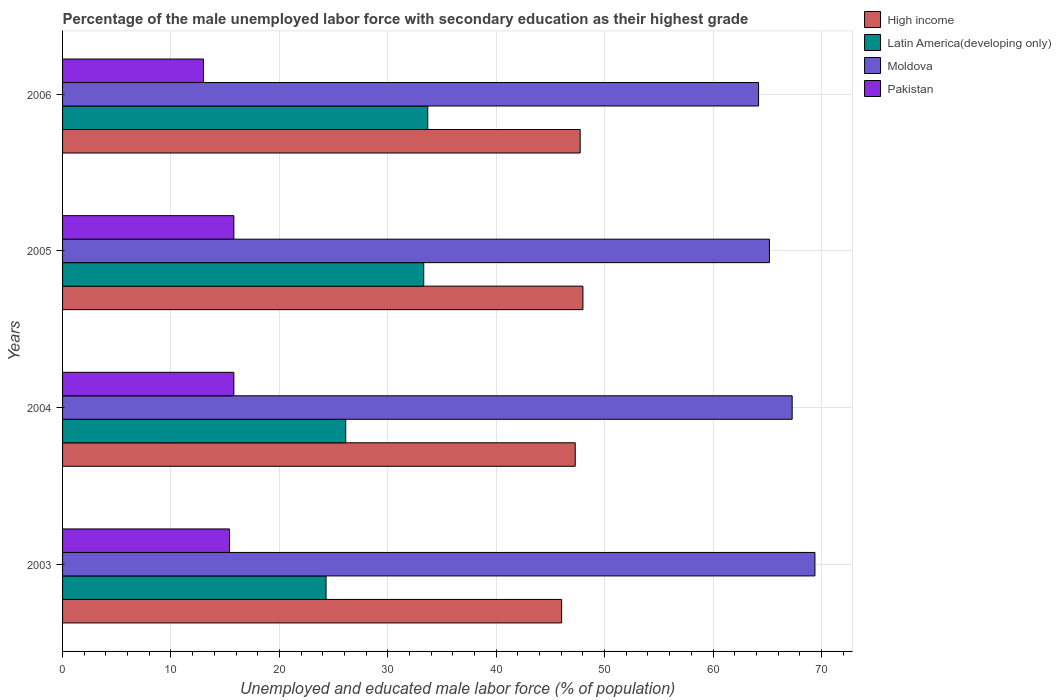Are the number of bars per tick equal to the number of legend labels?
Offer a terse response. Yes. What is the label of the 3rd group of bars from the top?
Provide a short and direct response. 2004. In how many cases, is the number of bars for a given year not equal to the number of legend labels?
Give a very brief answer. 0. What is the percentage of the unemployed male labor force with secondary education in Moldova in 2004?
Ensure brevity in your answer.  67.3. Across all years, what is the maximum percentage of the unemployed male labor force with secondary education in Pakistan?
Make the answer very short. 15.8. Across all years, what is the minimum percentage of the unemployed male labor force with secondary education in Latin America(developing only)?
Provide a succinct answer. 24.3. In which year was the percentage of the unemployed male labor force with secondary education in Moldova maximum?
Ensure brevity in your answer.  2003. In which year was the percentage of the unemployed male labor force with secondary education in Latin America(developing only) minimum?
Provide a succinct answer. 2003. What is the total percentage of the unemployed male labor force with secondary education in Pakistan in the graph?
Your answer should be very brief. 60. What is the difference between the percentage of the unemployed male labor force with secondary education in Latin America(developing only) in 2003 and that in 2005?
Give a very brief answer. -9.01. What is the difference between the percentage of the unemployed male labor force with secondary education in Pakistan in 2006 and the percentage of the unemployed male labor force with secondary education in Moldova in 2003?
Offer a very short reply. -56.4. What is the average percentage of the unemployed male labor force with secondary education in Pakistan per year?
Your answer should be compact. 15. In the year 2003, what is the difference between the percentage of the unemployed male labor force with secondary education in Latin America(developing only) and percentage of the unemployed male labor force with secondary education in Moldova?
Offer a terse response. -45.1. In how many years, is the percentage of the unemployed male labor force with secondary education in Pakistan greater than 22 %?
Offer a terse response. 0. What is the ratio of the percentage of the unemployed male labor force with secondary education in Moldova in 2004 to that in 2005?
Ensure brevity in your answer.  1.03. Is the percentage of the unemployed male labor force with secondary education in High income in 2004 less than that in 2005?
Offer a terse response. Yes. What is the difference between the highest and the second highest percentage of the unemployed male labor force with secondary education in Latin America(developing only)?
Your answer should be compact. 0.37. What is the difference between the highest and the lowest percentage of the unemployed male labor force with secondary education in Latin America(developing only)?
Keep it short and to the point. 9.38. In how many years, is the percentage of the unemployed male labor force with secondary education in High income greater than the average percentage of the unemployed male labor force with secondary education in High income taken over all years?
Ensure brevity in your answer.  3. Is the sum of the percentage of the unemployed male labor force with secondary education in High income in 2003 and 2006 greater than the maximum percentage of the unemployed male labor force with secondary education in Moldova across all years?
Offer a very short reply. Yes. Is it the case that in every year, the sum of the percentage of the unemployed male labor force with secondary education in Moldova and percentage of the unemployed male labor force with secondary education in Latin America(developing only) is greater than the sum of percentage of the unemployed male labor force with secondary education in High income and percentage of the unemployed male labor force with secondary education in Pakistan?
Your answer should be compact. No. What does the 2nd bar from the top in 2004 represents?
Your answer should be compact. Moldova. What does the 3rd bar from the bottom in 2006 represents?
Provide a succinct answer. Moldova. Is it the case that in every year, the sum of the percentage of the unemployed male labor force with secondary education in Latin America(developing only) and percentage of the unemployed male labor force with secondary education in High income is greater than the percentage of the unemployed male labor force with secondary education in Moldova?
Provide a short and direct response. Yes. What is the difference between two consecutive major ticks on the X-axis?
Ensure brevity in your answer.  10. How many legend labels are there?
Offer a very short reply. 4. How are the legend labels stacked?
Your response must be concise. Vertical. What is the title of the graph?
Your answer should be compact. Percentage of the male unemployed labor force with secondary education as their highest grade. Does "Ireland" appear as one of the legend labels in the graph?
Your answer should be compact. No. What is the label or title of the X-axis?
Your response must be concise. Unemployed and educated male labor force (% of population). What is the label or title of the Y-axis?
Your response must be concise. Years. What is the Unemployed and educated male labor force (% of population) of High income in 2003?
Keep it short and to the point. 46.04. What is the Unemployed and educated male labor force (% of population) of Latin America(developing only) in 2003?
Keep it short and to the point. 24.3. What is the Unemployed and educated male labor force (% of population) of Moldova in 2003?
Ensure brevity in your answer.  69.4. What is the Unemployed and educated male labor force (% of population) in Pakistan in 2003?
Your answer should be compact. 15.4. What is the Unemployed and educated male labor force (% of population) in High income in 2004?
Your answer should be compact. 47.29. What is the Unemployed and educated male labor force (% of population) in Latin America(developing only) in 2004?
Provide a short and direct response. 26.12. What is the Unemployed and educated male labor force (% of population) in Moldova in 2004?
Your answer should be very brief. 67.3. What is the Unemployed and educated male labor force (% of population) of Pakistan in 2004?
Give a very brief answer. 15.8. What is the Unemployed and educated male labor force (% of population) in High income in 2005?
Give a very brief answer. 48. What is the Unemployed and educated male labor force (% of population) in Latin America(developing only) in 2005?
Your answer should be very brief. 33.31. What is the Unemployed and educated male labor force (% of population) of Moldova in 2005?
Keep it short and to the point. 65.2. What is the Unemployed and educated male labor force (% of population) of Pakistan in 2005?
Offer a very short reply. 15.8. What is the Unemployed and educated male labor force (% of population) in High income in 2006?
Give a very brief answer. 47.74. What is the Unemployed and educated male labor force (% of population) in Latin America(developing only) in 2006?
Provide a succinct answer. 33.69. What is the Unemployed and educated male labor force (% of population) of Moldova in 2006?
Make the answer very short. 64.2. What is the Unemployed and educated male labor force (% of population) in Pakistan in 2006?
Offer a terse response. 13. Across all years, what is the maximum Unemployed and educated male labor force (% of population) in High income?
Keep it short and to the point. 48. Across all years, what is the maximum Unemployed and educated male labor force (% of population) of Latin America(developing only)?
Keep it short and to the point. 33.69. Across all years, what is the maximum Unemployed and educated male labor force (% of population) in Moldova?
Ensure brevity in your answer.  69.4. Across all years, what is the maximum Unemployed and educated male labor force (% of population) in Pakistan?
Ensure brevity in your answer.  15.8. Across all years, what is the minimum Unemployed and educated male labor force (% of population) in High income?
Offer a terse response. 46.04. Across all years, what is the minimum Unemployed and educated male labor force (% of population) in Latin America(developing only)?
Provide a succinct answer. 24.3. Across all years, what is the minimum Unemployed and educated male labor force (% of population) in Moldova?
Offer a terse response. 64.2. Across all years, what is the minimum Unemployed and educated male labor force (% of population) in Pakistan?
Offer a terse response. 13. What is the total Unemployed and educated male labor force (% of population) of High income in the graph?
Offer a very short reply. 189.07. What is the total Unemployed and educated male labor force (% of population) in Latin America(developing only) in the graph?
Keep it short and to the point. 117.43. What is the total Unemployed and educated male labor force (% of population) of Moldova in the graph?
Your response must be concise. 266.1. What is the total Unemployed and educated male labor force (% of population) of Pakistan in the graph?
Give a very brief answer. 60. What is the difference between the Unemployed and educated male labor force (% of population) of High income in 2003 and that in 2004?
Provide a short and direct response. -1.25. What is the difference between the Unemployed and educated male labor force (% of population) in Latin America(developing only) in 2003 and that in 2004?
Your response must be concise. -1.82. What is the difference between the Unemployed and educated male labor force (% of population) in Moldova in 2003 and that in 2004?
Offer a very short reply. 2.1. What is the difference between the Unemployed and educated male labor force (% of population) in Pakistan in 2003 and that in 2004?
Your answer should be compact. -0.4. What is the difference between the Unemployed and educated male labor force (% of population) of High income in 2003 and that in 2005?
Your answer should be very brief. -1.97. What is the difference between the Unemployed and educated male labor force (% of population) of Latin America(developing only) in 2003 and that in 2005?
Offer a very short reply. -9.01. What is the difference between the Unemployed and educated male labor force (% of population) of Pakistan in 2003 and that in 2005?
Your answer should be compact. -0.4. What is the difference between the Unemployed and educated male labor force (% of population) in High income in 2003 and that in 2006?
Make the answer very short. -1.71. What is the difference between the Unemployed and educated male labor force (% of population) of Latin America(developing only) in 2003 and that in 2006?
Make the answer very short. -9.38. What is the difference between the Unemployed and educated male labor force (% of population) in High income in 2004 and that in 2005?
Your response must be concise. -0.71. What is the difference between the Unemployed and educated male labor force (% of population) of Latin America(developing only) in 2004 and that in 2005?
Make the answer very short. -7.19. What is the difference between the Unemployed and educated male labor force (% of population) in Moldova in 2004 and that in 2005?
Your answer should be very brief. 2.1. What is the difference between the Unemployed and educated male labor force (% of population) of High income in 2004 and that in 2006?
Provide a short and direct response. -0.46. What is the difference between the Unemployed and educated male labor force (% of population) of Latin America(developing only) in 2004 and that in 2006?
Provide a succinct answer. -7.57. What is the difference between the Unemployed and educated male labor force (% of population) in Moldova in 2004 and that in 2006?
Give a very brief answer. 3.1. What is the difference between the Unemployed and educated male labor force (% of population) in High income in 2005 and that in 2006?
Your response must be concise. 0.26. What is the difference between the Unemployed and educated male labor force (% of population) of Latin America(developing only) in 2005 and that in 2006?
Provide a short and direct response. -0.37. What is the difference between the Unemployed and educated male labor force (% of population) in Pakistan in 2005 and that in 2006?
Keep it short and to the point. 2.8. What is the difference between the Unemployed and educated male labor force (% of population) of High income in 2003 and the Unemployed and educated male labor force (% of population) of Latin America(developing only) in 2004?
Ensure brevity in your answer.  19.91. What is the difference between the Unemployed and educated male labor force (% of population) in High income in 2003 and the Unemployed and educated male labor force (% of population) in Moldova in 2004?
Offer a terse response. -21.26. What is the difference between the Unemployed and educated male labor force (% of population) in High income in 2003 and the Unemployed and educated male labor force (% of population) in Pakistan in 2004?
Your answer should be very brief. 30.24. What is the difference between the Unemployed and educated male labor force (% of population) in Latin America(developing only) in 2003 and the Unemployed and educated male labor force (% of population) in Moldova in 2004?
Your answer should be compact. -43. What is the difference between the Unemployed and educated male labor force (% of population) of Latin America(developing only) in 2003 and the Unemployed and educated male labor force (% of population) of Pakistan in 2004?
Provide a succinct answer. 8.5. What is the difference between the Unemployed and educated male labor force (% of population) in Moldova in 2003 and the Unemployed and educated male labor force (% of population) in Pakistan in 2004?
Keep it short and to the point. 53.6. What is the difference between the Unemployed and educated male labor force (% of population) of High income in 2003 and the Unemployed and educated male labor force (% of population) of Latin America(developing only) in 2005?
Make the answer very short. 12.72. What is the difference between the Unemployed and educated male labor force (% of population) of High income in 2003 and the Unemployed and educated male labor force (% of population) of Moldova in 2005?
Give a very brief answer. -19.16. What is the difference between the Unemployed and educated male labor force (% of population) of High income in 2003 and the Unemployed and educated male labor force (% of population) of Pakistan in 2005?
Your response must be concise. 30.24. What is the difference between the Unemployed and educated male labor force (% of population) in Latin America(developing only) in 2003 and the Unemployed and educated male labor force (% of population) in Moldova in 2005?
Ensure brevity in your answer.  -40.9. What is the difference between the Unemployed and educated male labor force (% of population) in Latin America(developing only) in 2003 and the Unemployed and educated male labor force (% of population) in Pakistan in 2005?
Give a very brief answer. 8.5. What is the difference between the Unemployed and educated male labor force (% of population) in Moldova in 2003 and the Unemployed and educated male labor force (% of population) in Pakistan in 2005?
Ensure brevity in your answer.  53.6. What is the difference between the Unemployed and educated male labor force (% of population) in High income in 2003 and the Unemployed and educated male labor force (% of population) in Latin America(developing only) in 2006?
Your answer should be very brief. 12.35. What is the difference between the Unemployed and educated male labor force (% of population) of High income in 2003 and the Unemployed and educated male labor force (% of population) of Moldova in 2006?
Give a very brief answer. -18.16. What is the difference between the Unemployed and educated male labor force (% of population) of High income in 2003 and the Unemployed and educated male labor force (% of population) of Pakistan in 2006?
Make the answer very short. 33.04. What is the difference between the Unemployed and educated male labor force (% of population) in Latin America(developing only) in 2003 and the Unemployed and educated male labor force (% of population) in Moldova in 2006?
Keep it short and to the point. -39.9. What is the difference between the Unemployed and educated male labor force (% of population) of Latin America(developing only) in 2003 and the Unemployed and educated male labor force (% of population) of Pakistan in 2006?
Your response must be concise. 11.3. What is the difference between the Unemployed and educated male labor force (% of population) in Moldova in 2003 and the Unemployed and educated male labor force (% of population) in Pakistan in 2006?
Your answer should be very brief. 56.4. What is the difference between the Unemployed and educated male labor force (% of population) in High income in 2004 and the Unemployed and educated male labor force (% of population) in Latin America(developing only) in 2005?
Offer a terse response. 13.97. What is the difference between the Unemployed and educated male labor force (% of population) of High income in 2004 and the Unemployed and educated male labor force (% of population) of Moldova in 2005?
Your answer should be compact. -17.91. What is the difference between the Unemployed and educated male labor force (% of population) of High income in 2004 and the Unemployed and educated male labor force (% of population) of Pakistan in 2005?
Provide a succinct answer. 31.49. What is the difference between the Unemployed and educated male labor force (% of population) in Latin America(developing only) in 2004 and the Unemployed and educated male labor force (% of population) in Moldova in 2005?
Your response must be concise. -39.08. What is the difference between the Unemployed and educated male labor force (% of population) of Latin America(developing only) in 2004 and the Unemployed and educated male labor force (% of population) of Pakistan in 2005?
Your response must be concise. 10.32. What is the difference between the Unemployed and educated male labor force (% of population) of Moldova in 2004 and the Unemployed and educated male labor force (% of population) of Pakistan in 2005?
Give a very brief answer. 51.5. What is the difference between the Unemployed and educated male labor force (% of population) of High income in 2004 and the Unemployed and educated male labor force (% of population) of Latin America(developing only) in 2006?
Provide a succinct answer. 13.6. What is the difference between the Unemployed and educated male labor force (% of population) in High income in 2004 and the Unemployed and educated male labor force (% of population) in Moldova in 2006?
Keep it short and to the point. -16.91. What is the difference between the Unemployed and educated male labor force (% of population) of High income in 2004 and the Unemployed and educated male labor force (% of population) of Pakistan in 2006?
Your response must be concise. 34.29. What is the difference between the Unemployed and educated male labor force (% of population) of Latin America(developing only) in 2004 and the Unemployed and educated male labor force (% of population) of Moldova in 2006?
Give a very brief answer. -38.08. What is the difference between the Unemployed and educated male labor force (% of population) of Latin America(developing only) in 2004 and the Unemployed and educated male labor force (% of population) of Pakistan in 2006?
Your answer should be very brief. 13.12. What is the difference between the Unemployed and educated male labor force (% of population) in Moldova in 2004 and the Unemployed and educated male labor force (% of population) in Pakistan in 2006?
Provide a short and direct response. 54.3. What is the difference between the Unemployed and educated male labor force (% of population) in High income in 2005 and the Unemployed and educated male labor force (% of population) in Latin America(developing only) in 2006?
Offer a terse response. 14.31. What is the difference between the Unemployed and educated male labor force (% of population) in High income in 2005 and the Unemployed and educated male labor force (% of population) in Moldova in 2006?
Keep it short and to the point. -16.2. What is the difference between the Unemployed and educated male labor force (% of population) of High income in 2005 and the Unemployed and educated male labor force (% of population) of Pakistan in 2006?
Make the answer very short. 35. What is the difference between the Unemployed and educated male labor force (% of population) in Latin America(developing only) in 2005 and the Unemployed and educated male labor force (% of population) in Moldova in 2006?
Your response must be concise. -30.89. What is the difference between the Unemployed and educated male labor force (% of population) of Latin America(developing only) in 2005 and the Unemployed and educated male labor force (% of population) of Pakistan in 2006?
Your answer should be compact. 20.31. What is the difference between the Unemployed and educated male labor force (% of population) of Moldova in 2005 and the Unemployed and educated male labor force (% of population) of Pakistan in 2006?
Your answer should be compact. 52.2. What is the average Unemployed and educated male labor force (% of population) in High income per year?
Offer a very short reply. 47.27. What is the average Unemployed and educated male labor force (% of population) in Latin America(developing only) per year?
Your response must be concise. 29.36. What is the average Unemployed and educated male labor force (% of population) of Moldova per year?
Your answer should be compact. 66.53. What is the average Unemployed and educated male labor force (% of population) of Pakistan per year?
Provide a short and direct response. 15. In the year 2003, what is the difference between the Unemployed and educated male labor force (% of population) of High income and Unemployed and educated male labor force (% of population) of Latin America(developing only)?
Offer a terse response. 21.73. In the year 2003, what is the difference between the Unemployed and educated male labor force (% of population) in High income and Unemployed and educated male labor force (% of population) in Moldova?
Your answer should be very brief. -23.36. In the year 2003, what is the difference between the Unemployed and educated male labor force (% of population) of High income and Unemployed and educated male labor force (% of population) of Pakistan?
Your response must be concise. 30.64. In the year 2003, what is the difference between the Unemployed and educated male labor force (% of population) in Latin America(developing only) and Unemployed and educated male labor force (% of population) in Moldova?
Provide a short and direct response. -45.1. In the year 2003, what is the difference between the Unemployed and educated male labor force (% of population) in Latin America(developing only) and Unemployed and educated male labor force (% of population) in Pakistan?
Make the answer very short. 8.9. In the year 2004, what is the difference between the Unemployed and educated male labor force (% of population) in High income and Unemployed and educated male labor force (% of population) in Latin America(developing only)?
Make the answer very short. 21.17. In the year 2004, what is the difference between the Unemployed and educated male labor force (% of population) of High income and Unemployed and educated male labor force (% of population) of Moldova?
Provide a succinct answer. -20.01. In the year 2004, what is the difference between the Unemployed and educated male labor force (% of population) of High income and Unemployed and educated male labor force (% of population) of Pakistan?
Provide a succinct answer. 31.49. In the year 2004, what is the difference between the Unemployed and educated male labor force (% of population) of Latin America(developing only) and Unemployed and educated male labor force (% of population) of Moldova?
Make the answer very short. -41.18. In the year 2004, what is the difference between the Unemployed and educated male labor force (% of population) in Latin America(developing only) and Unemployed and educated male labor force (% of population) in Pakistan?
Your response must be concise. 10.32. In the year 2004, what is the difference between the Unemployed and educated male labor force (% of population) in Moldova and Unemployed and educated male labor force (% of population) in Pakistan?
Keep it short and to the point. 51.5. In the year 2005, what is the difference between the Unemployed and educated male labor force (% of population) in High income and Unemployed and educated male labor force (% of population) in Latin America(developing only)?
Make the answer very short. 14.69. In the year 2005, what is the difference between the Unemployed and educated male labor force (% of population) in High income and Unemployed and educated male labor force (% of population) in Moldova?
Your answer should be very brief. -17.2. In the year 2005, what is the difference between the Unemployed and educated male labor force (% of population) of High income and Unemployed and educated male labor force (% of population) of Pakistan?
Offer a very short reply. 32.2. In the year 2005, what is the difference between the Unemployed and educated male labor force (% of population) in Latin America(developing only) and Unemployed and educated male labor force (% of population) in Moldova?
Keep it short and to the point. -31.89. In the year 2005, what is the difference between the Unemployed and educated male labor force (% of population) of Latin America(developing only) and Unemployed and educated male labor force (% of population) of Pakistan?
Your answer should be very brief. 17.51. In the year 2005, what is the difference between the Unemployed and educated male labor force (% of population) of Moldova and Unemployed and educated male labor force (% of population) of Pakistan?
Give a very brief answer. 49.4. In the year 2006, what is the difference between the Unemployed and educated male labor force (% of population) in High income and Unemployed and educated male labor force (% of population) in Latin America(developing only)?
Ensure brevity in your answer.  14.06. In the year 2006, what is the difference between the Unemployed and educated male labor force (% of population) in High income and Unemployed and educated male labor force (% of population) in Moldova?
Offer a very short reply. -16.46. In the year 2006, what is the difference between the Unemployed and educated male labor force (% of population) of High income and Unemployed and educated male labor force (% of population) of Pakistan?
Your response must be concise. 34.74. In the year 2006, what is the difference between the Unemployed and educated male labor force (% of population) of Latin America(developing only) and Unemployed and educated male labor force (% of population) of Moldova?
Your response must be concise. -30.51. In the year 2006, what is the difference between the Unemployed and educated male labor force (% of population) in Latin America(developing only) and Unemployed and educated male labor force (% of population) in Pakistan?
Your answer should be compact. 20.69. In the year 2006, what is the difference between the Unemployed and educated male labor force (% of population) of Moldova and Unemployed and educated male labor force (% of population) of Pakistan?
Provide a succinct answer. 51.2. What is the ratio of the Unemployed and educated male labor force (% of population) of High income in 2003 to that in 2004?
Provide a short and direct response. 0.97. What is the ratio of the Unemployed and educated male labor force (% of population) of Latin America(developing only) in 2003 to that in 2004?
Keep it short and to the point. 0.93. What is the ratio of the Unemployed and educated male labor force (% of population) of Moldova in 2003 to that in 2004?
Keep it short and to the point. 1.03. What is the ratio of the Unemployed and educated male labor force (% of population) of Pakistan in 2003 to that in 2004?
Give a very brief answer. 0.97. What is the ratio of the Unemployed and educated male labor force (% of population) of High income in 2003 to that in 2005?
Give a very brief answer. 0.96. What is the ratio of the Unemployed and educated male labor force (% of population) of Latin America(developing only) in 2003 to that in 2005?
Your response must be concise. 0.73. What is the ratio of the Unemployed and educated male labor force (% of population) in Moldova in 2003 to that in 2005?
Provide a succinct answer. 1.06. What is the ratio of the Unemployed and educated male labor force (% of population) in Pakistan in 2003 to that in 2005?
Offer a very short reply. 0.97. What is the ratio of the Unemployed and educated male labor force (% of population) of High income in 2003 to that in 2006?
Your answer should be very brief. 0.96. What is the ratio of the Unemployed and educated male labor force (% of population) in Latin America(developing only) in 2003 to that in 2006?
Offer a terse response. 0.72. What is the ratio of the Unemployed and educated male labor force (% of population) of Moldova in 2003 to that in 2006?
Offer a terse response. 1.08. What is the ratio of the Unemployed and educated male labor force (% of population) of Pakistan in 2003 to that in 2006?
Your answer should be compact. 1.18. What is the ratio of the Unemployed and educated male labor force (% of population) of High income in 2004 to that in 2005?
Ensure brevity in your answer.  0.99. What is the ratio of the Unemployed and educated male labor force (% of population) of Latin America(developing only) in 2004 to that in 2005?
Make the answer very short. 0.78. What is the ratio of the Unemployed and educated male labor force (% of population) of Moldova in 2004 to that in 2005?
Offer a terse response. 1.03. What is the ratio of the Unemployed and educated male labor force (% of population) in Pakistan in 2004 to that in 2005?
Your response must be concise. 1. What is the ratio of the Unemployed and educated male labor force (% of population) of Latin America(developing only) in 2004 to that in 2006?
Make the answer very short. 0.78. What is the ratio of the Unemployed and educated male labor force (% of population) of Moldova in 2004 to that in 2006?
Your answer should be very brief. 1.05. What is the ratio of the Unemployed and educated male labor force (% of population) of Pakistan in 2004 to that in 2006?
Your response must be concise. 1.22. What is the ratio of the Unemployed and educated male labor force (% of population) of High income in 2005 to that in 2006?
Give a very brief answer. 1.01. What is the ratio of the Unemployed and educated male labor force (% of population) in Latin America(developing only) in 2005 to that in 2006?
Ensure brevity in your answer.  0.99. What is the ratio of the Unemployed and educated male labor force (% of population) in Moldova in 2005 to that in 2006?
Offer a very short reply. 1.02. What is the ratio of the Unemployed and educated male labor force (% of population) of Pakistan in 2005 to that in 2006?
Offer a very short reply. 1.22. What is the difference between the highest and the second highest Unemployed and educated male labor force (% of population) in High income?
Your response must be concise. 0.26. What is the difference between the highest and the second highest Unemployed and educated male labor force (% of population) of Latin America(developing only)?
Give a very brief answer. 0.37. What is the difference between the highest and the lowest Unemployed and educated male labor force (% of population) in High income?
Your answer should be compact. 1.97. What is the difference between the highest and the lowest Unemployed and educated male labor force (% of population) of Latin America(developing only)?
Provide a short and direct response. 9.38. 